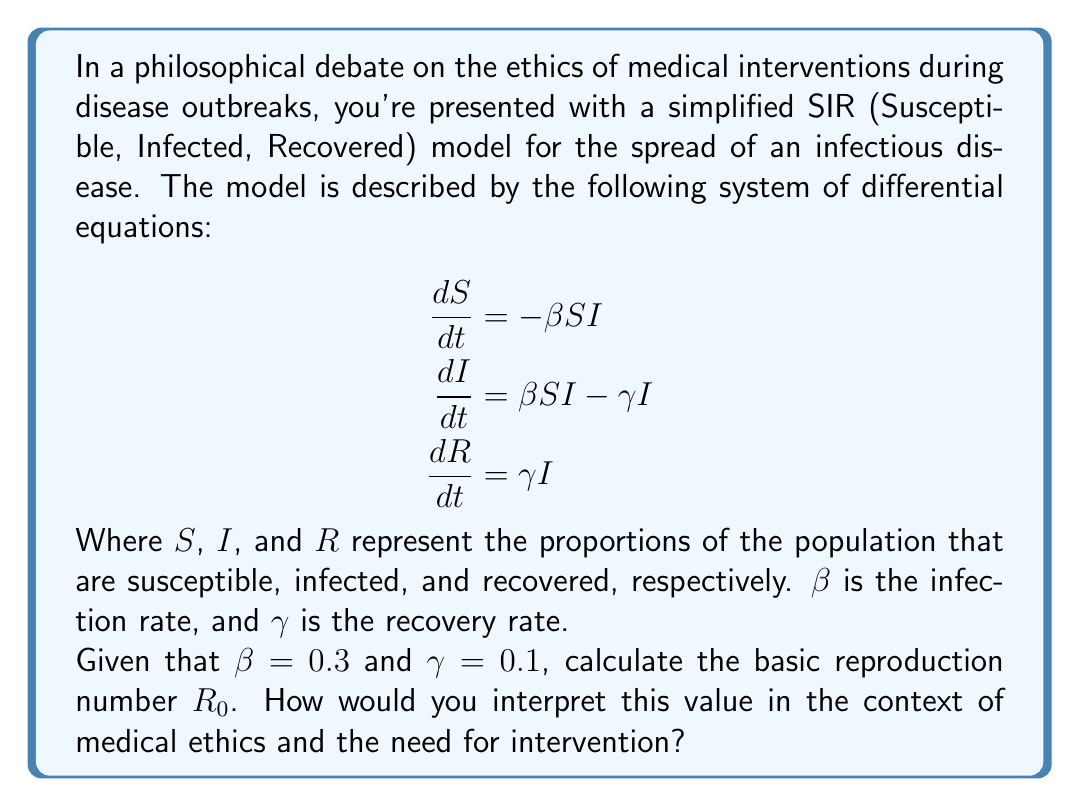Give your solution to this math problem. To answer this question, we need to understand the concept of the basic reproduction number $R_0$ and how it relates to the given differential equations.

1) The basic reproduction number $R_0$ is defined as the average number of secondary infections caused by one infected individual in a completely susceptible population.

2) In the SIR model, $R_0$ can be calculated using the formula:

   $$R_0 = \frac{\beta}{\gamma}$$

   Where $\beta$ is the infection rate and $\gamma$ is the recovery rate.

3) Given the values $\beta = 0.3$ and $\gamma = 0.1$, we can calculate $R_0$:

   $$R_0 = \frac{0.3}{0.1} = 3$$

4) Interpretation of $R_0$:
   - If $R_0 > 1$, the disease will spread exponentially in the population.
   - If $R_0 < 1$, the disease will die out over time.
   - If $R_0 = 1$, the disease will become endemic, maintaining a stable number of infections.

5) In this case, $R_0 = 3$, which means that, on average, each infected person will infect 3 others before recovering.

6) From an ethical perspective, this value has several implications:
   - It suggests that without intervention, the disease will spread rapidly through the population.
   - This could potentially overwhelm healthcare systems and lead to significant morbidity and mortality.
   - It raises questions about the ethical obligation to implement interventions (e.g., quarantine, vaccination) to reduce the spread.
   - It also brings up debates about individual liberty versus collective wellbeing, as interventions may restrict personal freedoms.

7) The $R_0$ value provides evidence for the potential impact of the disease, which is crucial in ethical debates about medical interventions. It offers a quantitative basis for discussing the necessity and proportionality of public health measures.
Answer: The basic reproduction number $R_0 = 3$. This value indicates that the disease will spread exponentially without intervention, with each infected individual infecting an average of 3 others. In the context of medical ethics, this provides quantitative evidence for the potential severity of the outbreak and the need for intervention, while also raising important questions about balancing public health measures with individual rights and freedoms. 